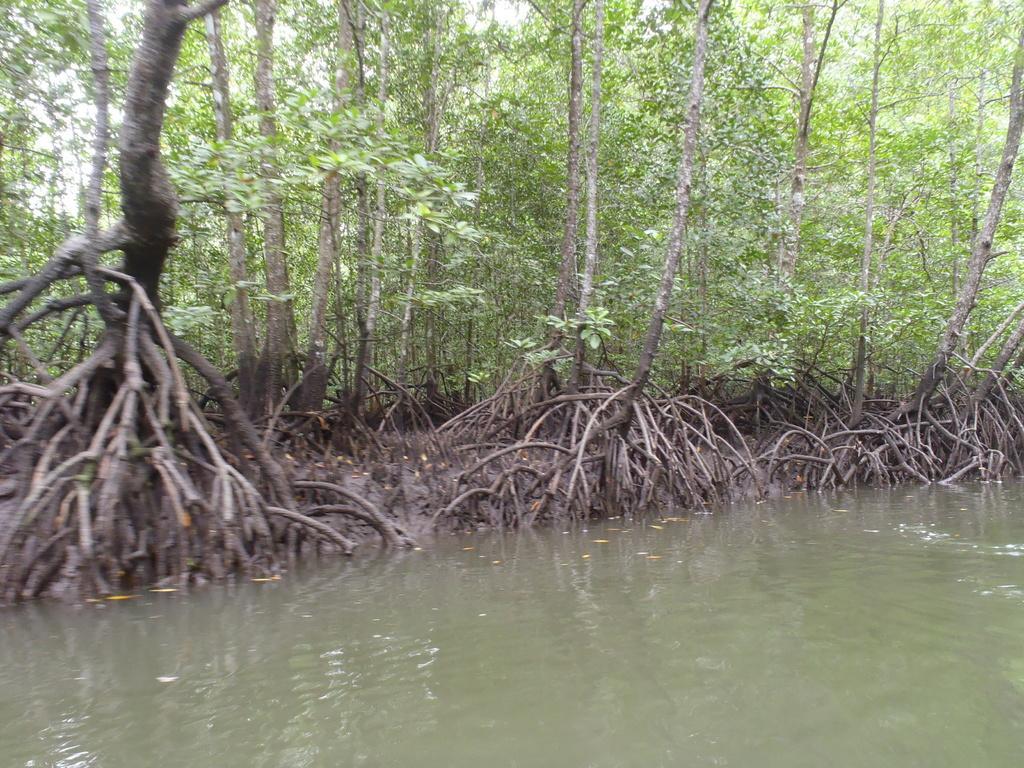Describe this image in one or two sentences. In this image I can see few green trees and the water. 